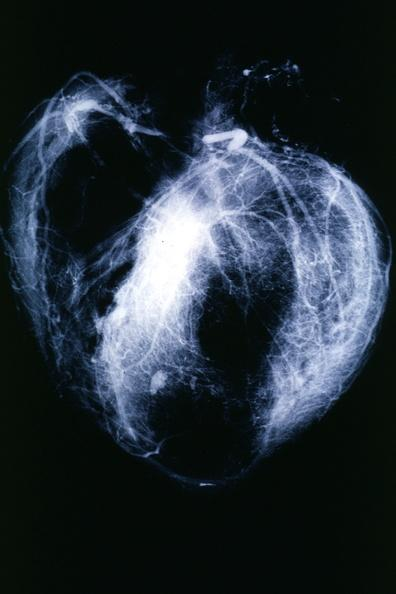s angiogram present?
Answer the question using a single word or phrase. Yes 